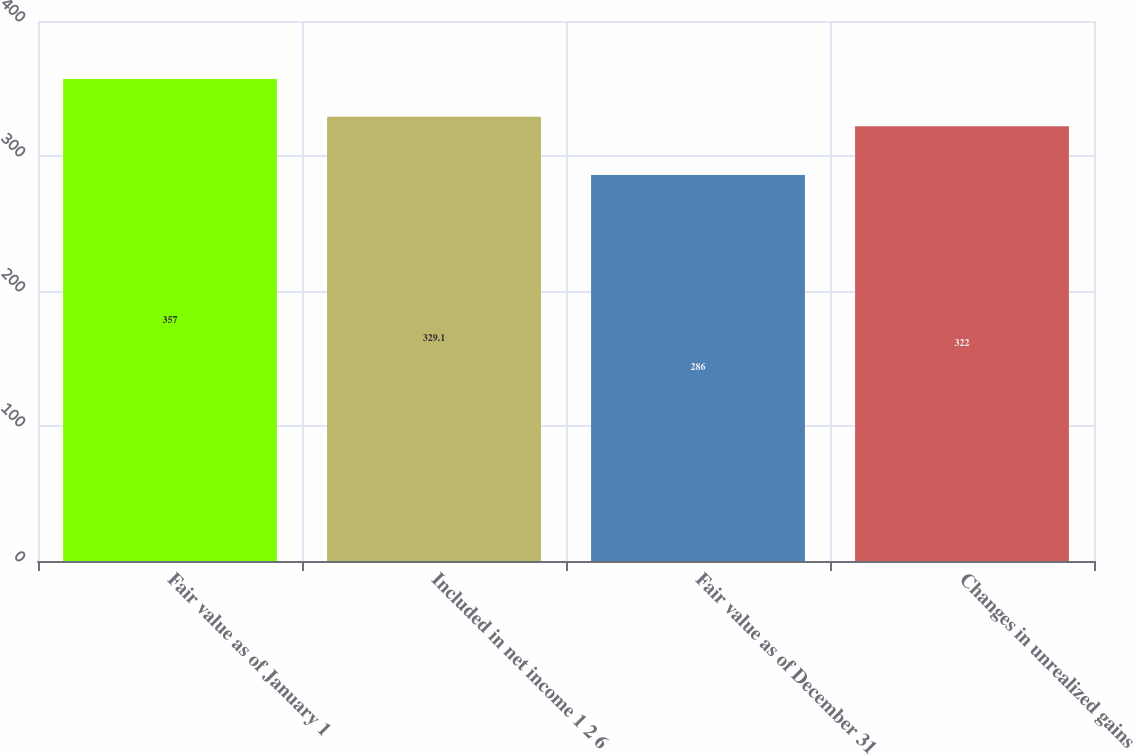Convert chart. <chart><loc_0><loc_0><loc_500><loc_500><bar_chart><fcel>Fair value as of January 1<fcel>Included in net income 1 2 6<fcel>Fair value as of December 31<fcel>Changes in unrealized gains<nl><fcel>357<fcel>329.1<fcel>286<fcel>322<nl></chart> 